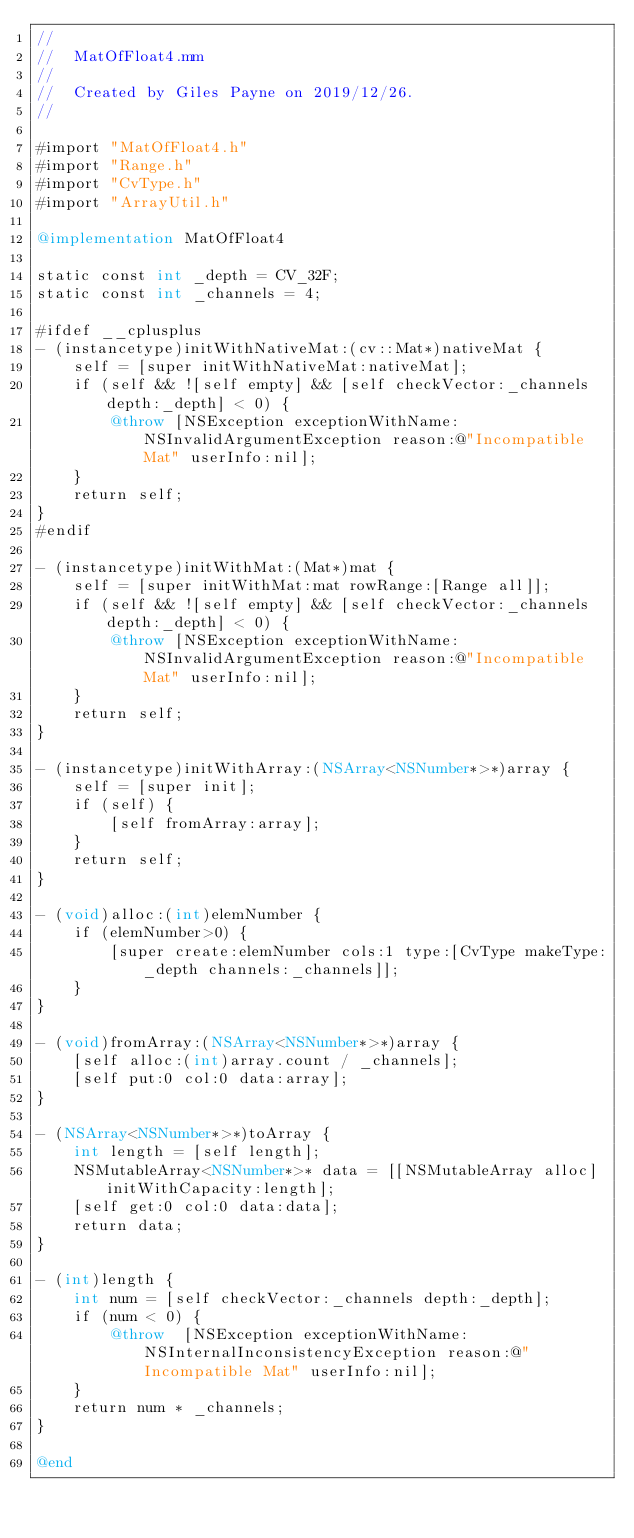<code> <loc_0><loc_0><loc_500><loc_500><_ObjectiveC_>//
//  MatOfFloat4.mm
//
//  Created by Giles Payne on 2019/12/26.
//

#import "MatOfFloat4.h"
#import "Range.h"
#import "CvType.h"
#import "ArrayUtil.h"

@implementation MatOfFloat4

static const int _depth = CV_32F;
static const int _channels = 4;

#ifdef __cplusplus
- (instancetype)initWithNativeMat:(cv::Mat*)nativeMat {
    self = [super initWithNativeMat:nativeMat];
    if (self && ![self empty] && [self checkVector:_channels depth:_depth] < 0) {
        @throw [NSException exceptionWithName:NSInvalidArgumentException reason:@"Incompatible Mat" userInfo:nil];
    }
    return self;
}
#endif

- (instancetype)initWithMat:(Mat*)mat {
    self = [super initWithMat:mat rowRange:[Range all]];
    if (self && ![self empty] && [self checkVector:_channels depth:_depth] < 0) {
        @throw [NSException exceptionWithName:NSInvalidArgumentException reason:@"Incompatible Mat" userInfo:nil];
    }
    return self;
}

- (instancetype)initWithArray:(NSArray<NSNumber*>*)array {
    self = [super init];
    if (self) {
        [self fromArray:array];
    }
    return self;
}

- (void)alloc:(int)elemNumber {
    if (elemNumber>0) {
        [super create:elemNumber cols:1 type:[CvType makeType:_depth channels:_channels]];
    }
}

- (void)fromArray:(NSArray<NSNumber*>*)array {
    [self alloc:(int)array.count / _channels];
    [self put:0 col:0 data:array];
}

- (NSArray<NSNumber*>*)toArray {
    int length = [self length];
    NSMutableArray<NSNumber*>* data = [[NSMutableArray alloc] initWithCapacity:length];
    [self get:0 col:0 data:data];
    return data;
}

- (int)length {
    int num = [self checkVector:_channels depth:_depth];
    if (num < 0) {
        @throw  [NSException exceptionWithName:NSInternalInconsistencyException reason:@"Incompatible Mat" userInfo:nil];
    }
    return num * _channels;
}

@end
</code> 